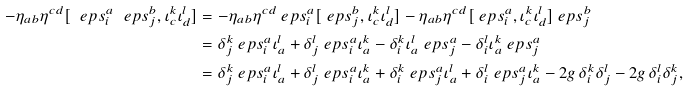<formula> <loc_0><loc_0><loc_500><loc_500>- \eta _ { a b } \eta ^ { c d } [ \ e p s ^ { a } _ { i } \ e p s ^ { b } _ { j } , \iota ^ { k } _ { c } \iota ^ { l } _ { d } ] & = - \eta _ { a b } \eta ^ { c d } \ e p s ^ { a } _ { i } [ \ e p s ^ { b } _ { j } , \iota ^ { k } _ { c } \iota ^ { l } _ { d } ] - \eta _ { a b } \eta ^ { c d } [ \ e p s ^ { a } _ { i } , \iota ^ { k } _ { c } \iota ^ { l } _ { d } ] \ e p s ^ { b } _ { j } \\ & = \delta ^ { k } _ { j } \ e p s ^ { a } _ { i } \iota ^ { l } _ { a } + \delta ^ { l } _ { j } \ e p s ^ { a } _ { i } \iota ^ { k } _ { a } - \delta ^ { k } _ { i } \iota ^ { l } _ { a } \ e p s ^ { a } _ { j } - \delta ^ { l } _ { i } \iota ^ { k } _ { a } \ e p s ^ { a } _ { j } \\ & = \delta ^ { k } _ { j } \ e p s ^ { a } _ { i } \iota ^ { l } _ { a } + \delta ^ { l } _ { j } \ e p s ^ { a } _ { i } \iota ^ { k } _ { a } + \delta ^ { k } _ { i } \ e p s ^ { a } _ { j } \iota ^ { l } _ { a } + \delta ^ { l } _ { i } \ e p s ^ { a } _ { j } \iota ^ { k } _ { a } - 2 g \, \delta ^ { k } _ { i } \delta ^ { l } _ { j } - 2 g \, \delta ^ { l } _ { i } \delta ^ { k } _ { j } ,</formula> 